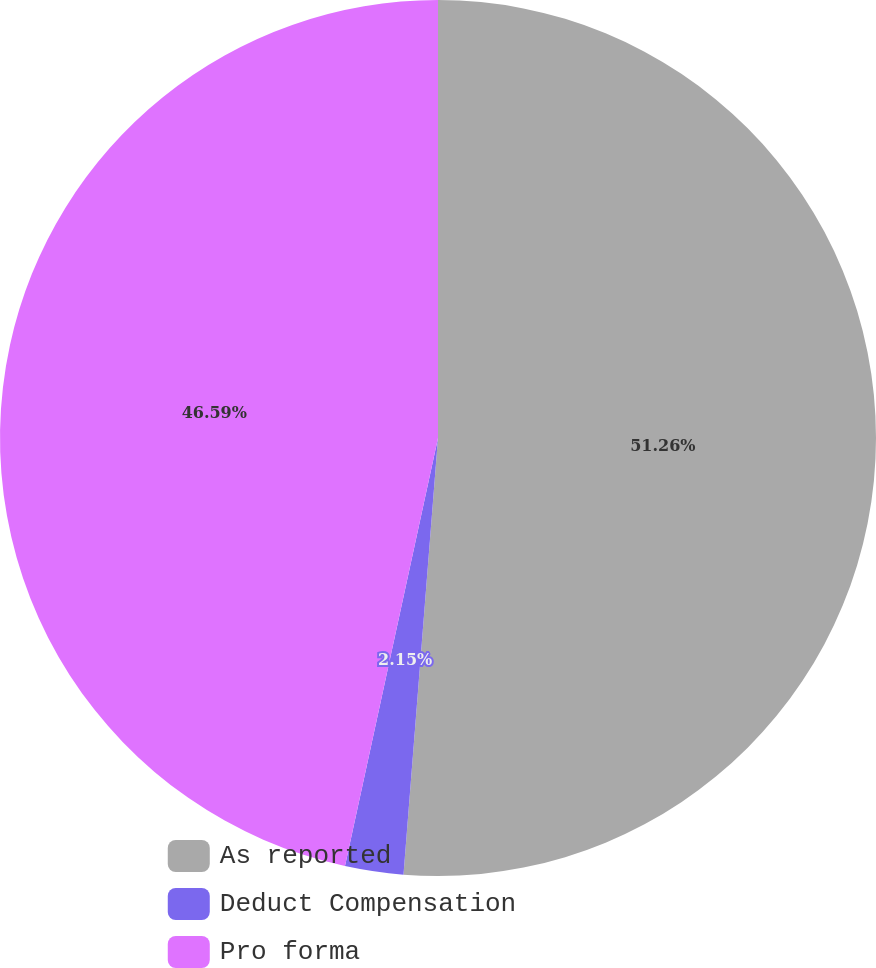Convert chart. <chart><loc_0><loc_0><loc_500><loc_500><pie_chart><fcel>As reported<fcel>Deduct Compensation<fcel>Pro forma<nl><fcel>51.25%<fcel>2.15%<fcel>46.59%<nl></chart> 